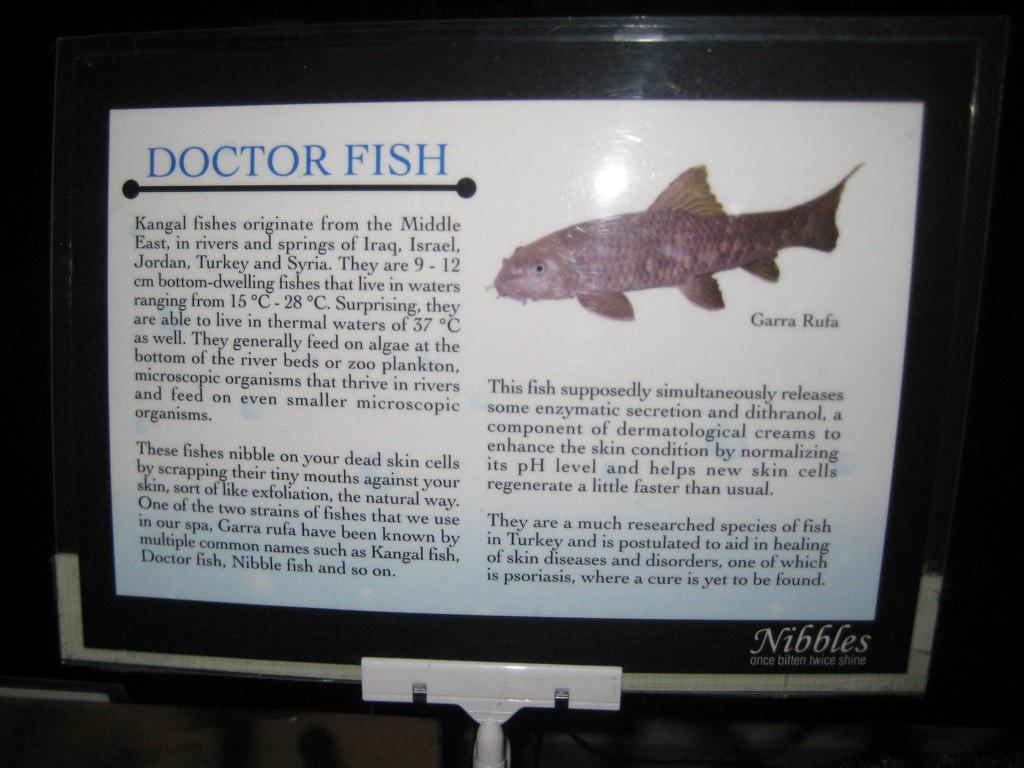What is the main object in the image? There is a board in the image. What can be found on the board? The board has text and an image on it. How many fingers are visible on the board in the image? There are no fingers visible on the board in the image. What territory is being claimed by the board in the image? The image does not depict any territorial claims or protests. 